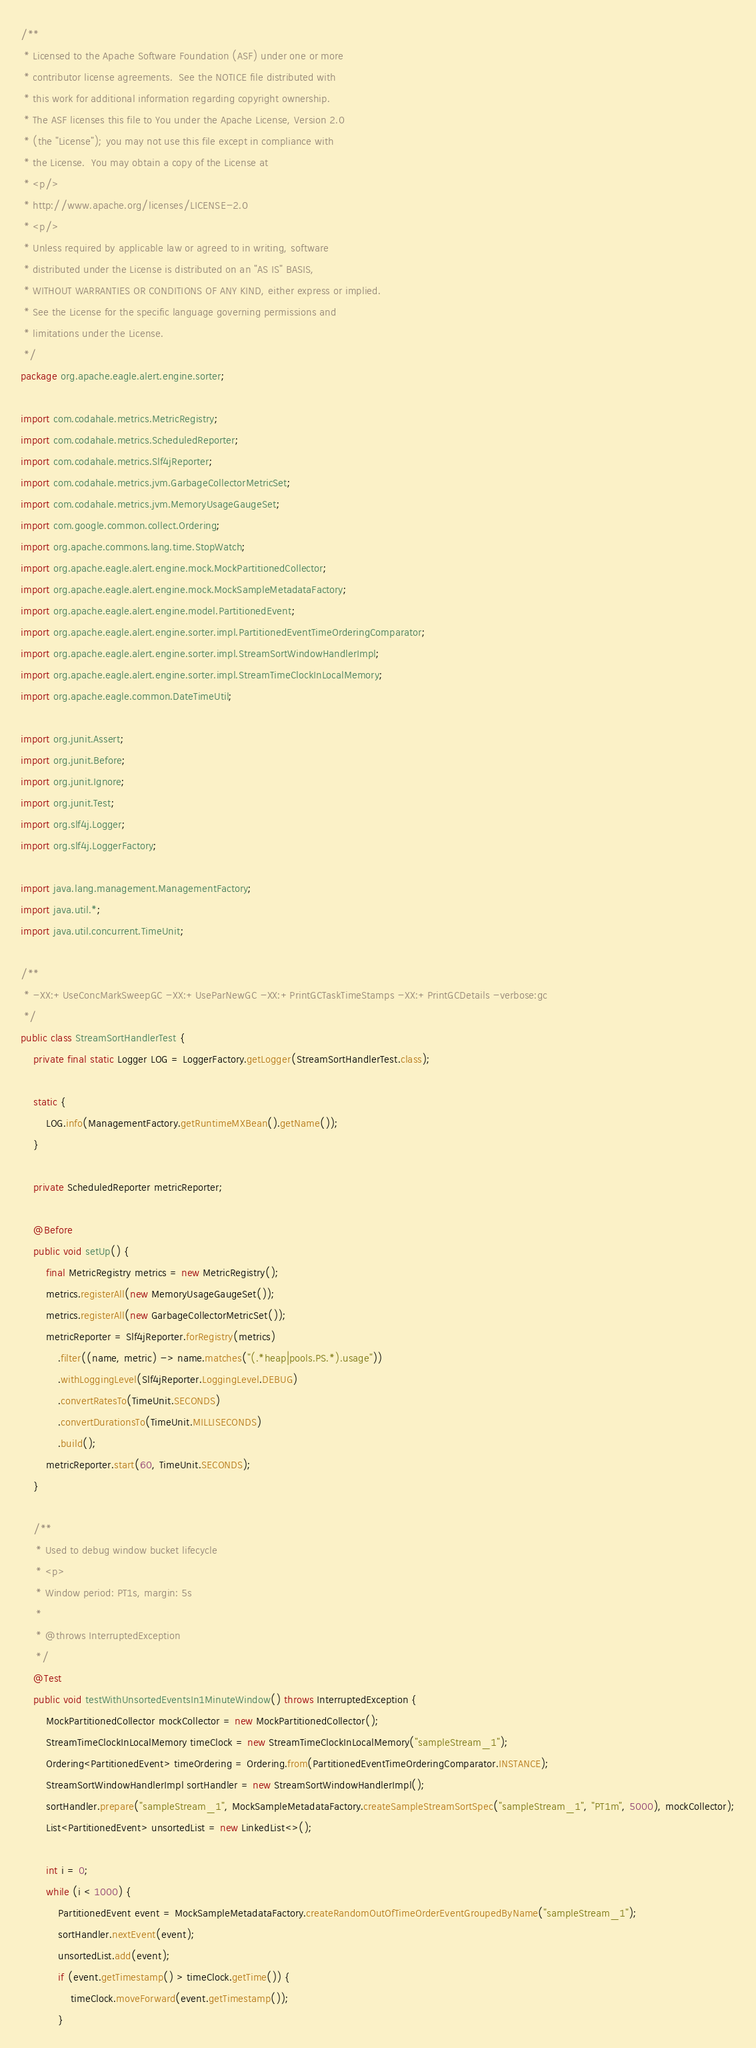<code> <loc_0><loc_0><loc_500><loc_500><_Java_>/**
 * Licensed to the Apache Software Foundation (ASF) under one or more
 * contributor license agreements.  See the NOTICE file distributed with
 * this work for additional information regarding copyright ownership.
 * The ASF licenses this file to You under the Apache License, Version 2.0
 * (the "License"); you may not use this file except in compliance with
 * the License.  You may obtain a copy of the License at
 * <p/>
 * http://www.apache.org/licenses/LICENSE-2.0
 * <p/>
 * Unless required by applicable law or agreed to in writing, software
 * distributed under the License is distributed on an "AS IS" BASIS,
 * WITHOUT WARRANTIES OR CONDITIONS OF ANY KIND, either express or implied.
 * See the License for the specific language governing permissions and
 * limitations under the License.
 */
package org.apache.eagle.alert.engine.sorter;

import com.codahale.metrics.MetricRegistry;
import com.codahale.metrics.ScheduledReporter;
import com.codahale.metrics.Slf4jReporter;
import com.codahale.metrics.jvm.GarbageCollectorMetricSet;
import com.codahale.metrics.jvm.MemoryUsageGaugeSet;
import com.google.common.collect.Ordering;
import org.apache.commons.lang.time.StopWatch;
import org.apache.eagle.alert.engine.mock.MockPartitionedCollector;
import org.apache.eagle.alert.engine.mock.MockSampleMetadataFactory;
import org.apache.eagle.alert.engine.model.PartitionedEvent;
import org.apache.eagle.alert.engine.sorter.impl.PartitionedEventTimeOrderingComparator;
import org.apache.eagle.alert.engine.sorter.impl.StreamSortWindowHandlerImpl;
import org.apache.eagle.alert.engine.sorter.impl.StreamTimeClockInLocalMemory;
import org.apache.eagle.common.DateTimeUtil;

import org.junit.Assert;
import org.junit.Before;
import org.junit.Ignore;
import org.junit.Test;
import org.slf4j.Logger;
import org.slf4j.LoggerFactory;

import java.lang.management.ManagementFactory;
import java.util.*;
import java.util.concurrent.TimeUnit;

/**
 * -XX:+UseConcMarkSweepGC -XX:+UseParNewGC -XX:+PrintGCTaskTimeStamps -XX:+PrintGCDetails -verbose:gc
 */
public class StreamSortHandlerTest {
    private final static Logger LOG = LoggerFactory.getLogger(StreamSortHandlerTest.class);

    static {
        LOG.info(ManagementFactory.getRuntimeMXBean().getName());
    }

    private ScheduledReporter metricReporter;

    @Before
    public void setUp() {
        final MetricRegistry metrics = new MetricRegistry();
        metrics.registerAll(new MemoryUsageGaugeSet());
        metrics.registerAll(new GarbageCollectorMetricSet());
        metricReporter = Slf4jReporter.forRegistry(metrics)
            .filter((name, metric) -> name.matches("(.*heap|pools.PS.*).usage"))
            .withLoggingLevel(Slf4jReporter.LoggingLevel.DEBUG)
            .convertRatesTo(TimeUnit.SECONDS)
            .convertDurationsTo(TimeUnit.MILLISECONDS)
            .build();
        metricReporter.start(60, TimeUnit.SECONDS);
    }

    /**
     * Used to debug window bucket lifecycle
     * <p>
     * Window period: PT1s, margin: 5s
     *
     * @throws InterruptedException
     */
    @Test
    public void testWithUnsortedEventsIn1MinuteWindow() throws InterruptedException {
        MockPartitionedCollector mockCollector = new MockPartitionedCollector();
        StreamTimeClockInLocalMemory timeClock = new StreamTimeClockInLocalMemory("sampleStream_1");
        Ordering<PartitionedEvent> timeOrdering = Ordering.from(PartitionedEventTimeOrderingComparator.INSTANCE);
        StreamSortWindowHandlerImpl sortHandler = new StreamSortWindowHandlerImpl();
        sortHandler.prepare("sampleStream_1", MockSampleMetadataFactory.createSampleStreamSortSpec("sampleStream_1", "PT1m", 5000), mockCollector);
        List<PartitionedEvent> unsortedList = new LinkedList<>();

        int i = 0;
        while (i < 1000) {
            PartitionedEvent event = MockSampleMetadataFactory.createRandomOutOfTimeOrderEventGroupedByName("sampleStream_1");
            sortHandler.nextEvent(event);
            unsortedList.add(event);
            if (event.getTimestamp() > timeClock.getTime()) {
                timeClock.moveForward(event.getTimestamp());
            }</code> 